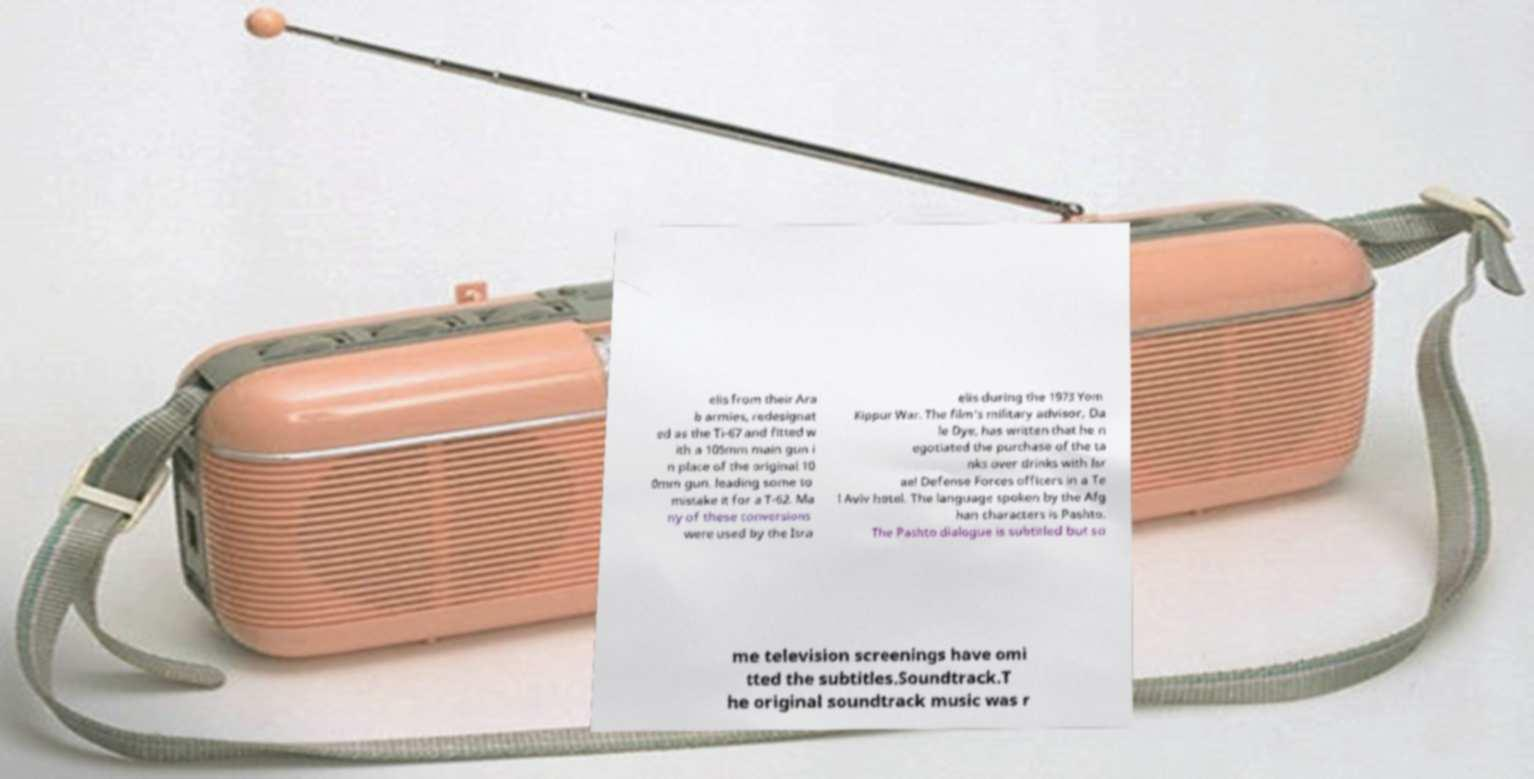What messages or text are displayed in this image? I need them in a readable, typed format. elis from their Ara b armies, redesignat ed as the Ti-67 and fitted w ith a 105mm main gun i n place of the original 10 0mm gun, leading some to mistake it for a T-62. Ma ny of these conversions were used by the Isra elis during the 1973 Yom Kippur War. The film's military advisor, Da le Dye, has written that he n egotiated the purchase of the ta nks over drinks with Isr ael Defense Forces officers in a Te l Aviv hotel. The language spoken by the Afg han characters is Pashto. The Pashto dialogue is subtitled but so me television screenings have omi tted the subtitles.Soundtrack.T he original soundtrack music was r 